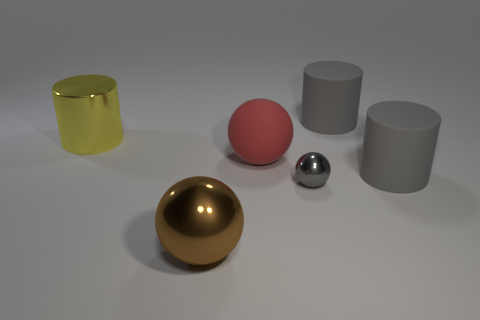What is the material of the large sphere behind the big ball that is in front of the large rubber ball?
Provide a succinct answer. Rubber. Is the tiny gray thing made of the same material as the thing that is behind the yellow metallic cylinder?
Offer a very short reply. No. What number of objects are either metallic things behind the gray sphere or big brown balls?
Your answer should be very brief. 2. Is there a shiny object that has the same color as the small metallic ball?
Make the answer very short. No. Do the big brown metal object and the metallic thing that is to the right of the big red ball have the same shape?
Provide a succinct answer. Yes. What number of things are both on the right side of the brown thing and behind the small metal thing?
Your answer should be compact. 3. What material is the gray thing that is the same shape as the big brown metallic thing?
Offer a very short reply. Metal. What is the size of the gray matte thing in front of the big cylinder that is to the left of the tiny gray shiny ball?
Your response must be concise. Large. Are there any matte objects?
Offer a terse response. Yes. The large thing that is in front of the large red thing and on the right side of the large brown ball is made of what material?
Provide a succinct answer. Rubber. 